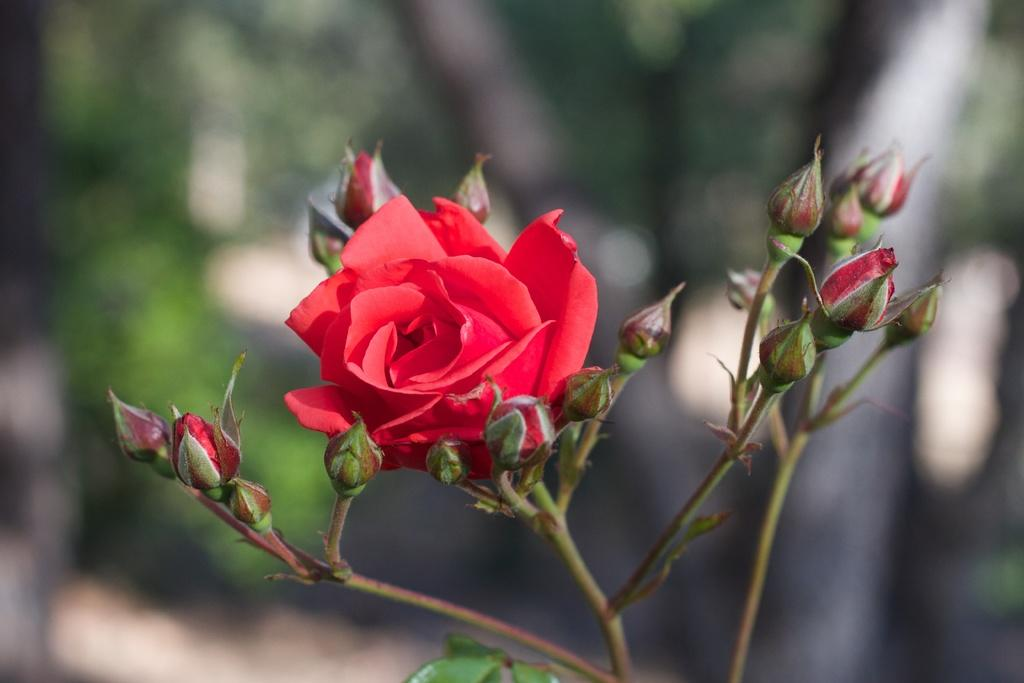What is the main subject of the image? There is a plant in the image. What color is the flower on the plant? The plant has a red flower. Can you describe the background of the image? The background of the image is blurred. What type of thunder can be heard in the image? There is no thunder present in the image, as it is a still photograph of a plant. How many knots are visible on the plant's stem? The image does not show any knots on the plant's stem, as it only depicts the plant and its red flower. 